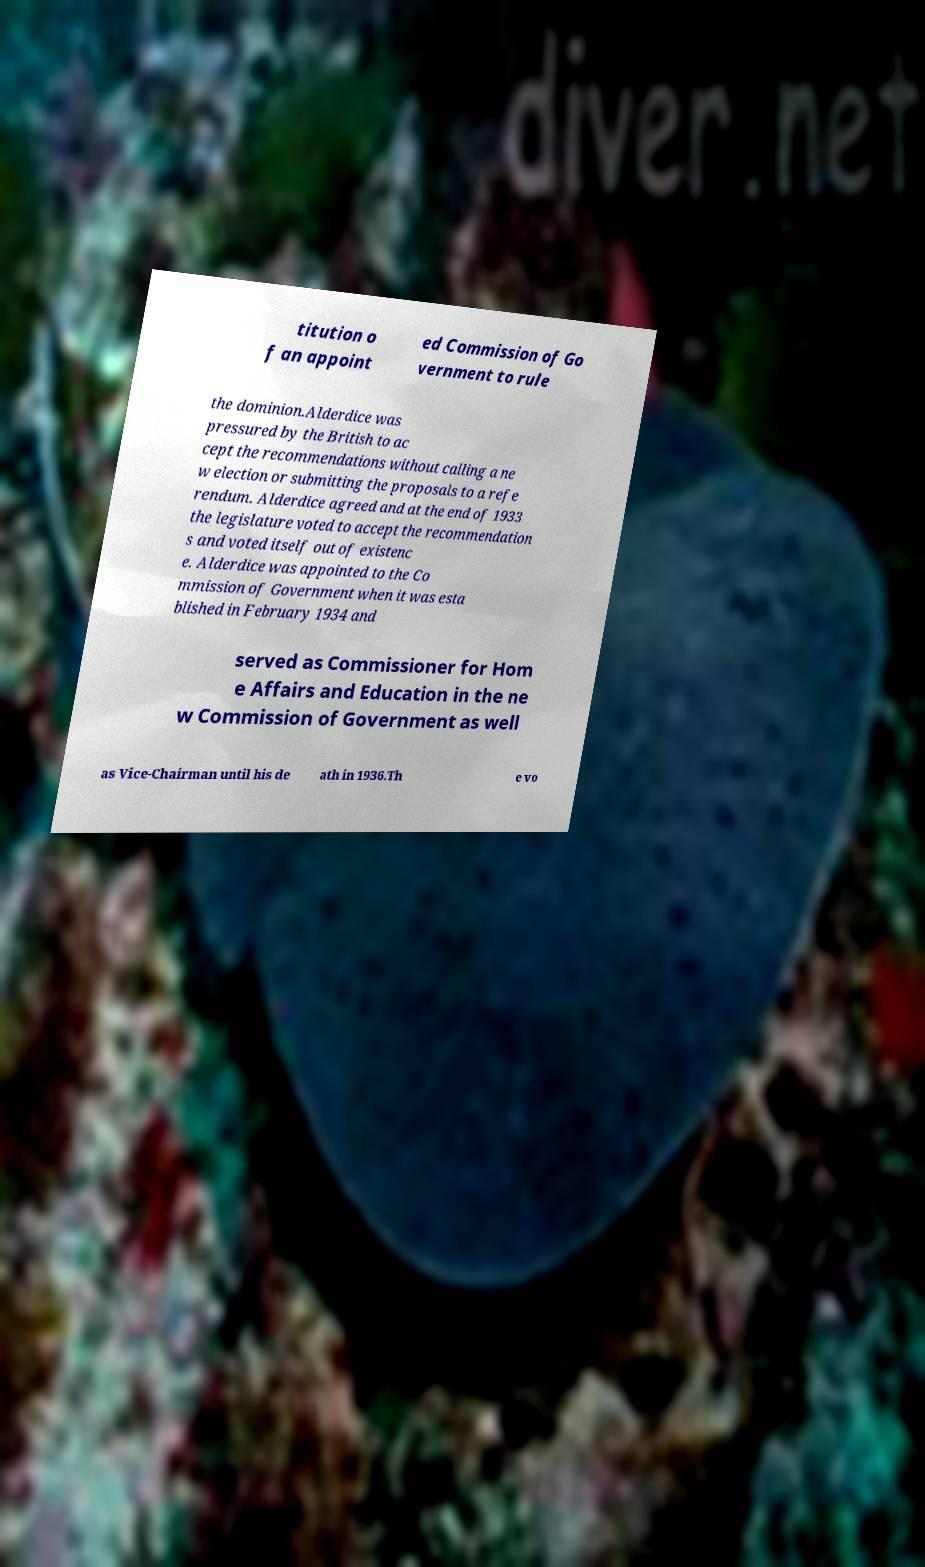Can you read and provide the text displayed in the image?This photo seems to have some interesting text. Can you extract and type it out for me? titution o f an appoint ed Commission of Go vernment to rule the dominion.Alderdice was pressured by the British to ac cept the recommendations without calling a ne w election or submitting the proposals to a refe rendum. Alderdice agreed and at the end of 1933 the legislature voted to accept the recommendation s and voted itself out of existenc e. Alderdice was appointed to the Co mmission of Government when it was esta blished in February 1934 and served as Commissioner for Hom e Affairs and Education in the ne w Commission of Government as well as Vice-Chairman until his de ath in 1936.Th e vo 